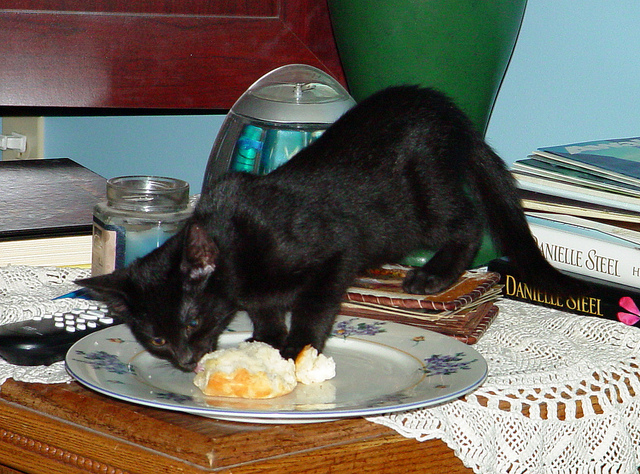Extract all visible text content from this image. DANIELLE STEEL STEEL DANIELLE 